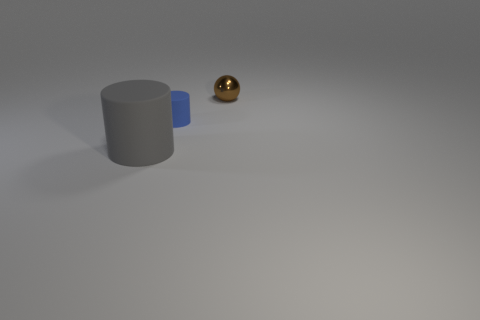Add 2 big cylinders. How many objects exist? 5 Subtract all spheres. How many objects are left? 2 Add 3 small brown balls. How many small brown balls are left? 4 Add 3 large blue cylinders. How many large blue cylinders exist? 3 Subtract 0 blue spheres. How many objects are left? 3 Subtract all big metallic things. Subtract all big gray things. How many objects are left? 2 